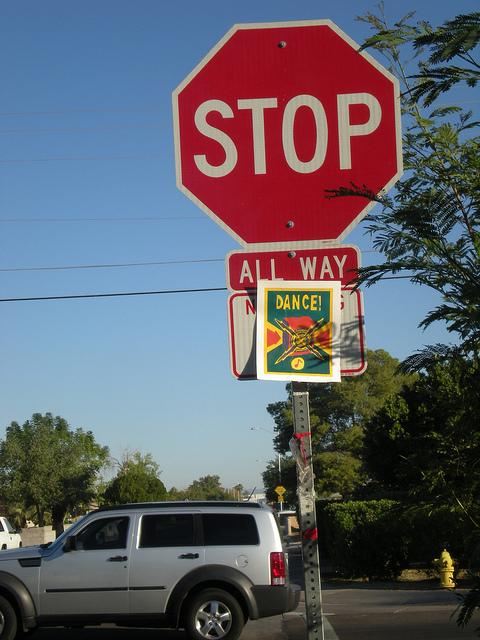How many people must stop at the intersection?

Choices:
A) two
B) four
C) three
D) one four 